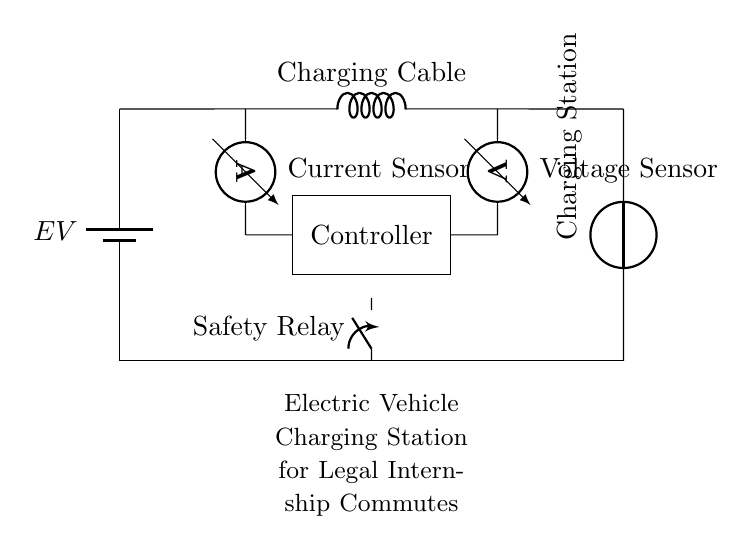What is the primary component generating power in this circuit? The primary component generating power is the charging station, which is depicted as a voltage source in the circuit.
Answer: Charging Station What type of sensor is used to measure current? The current sensor in the circuit is an ammeter, which is specifically designed to measure the flow of electric current.
Answer: Ammeter What does the safety relay do in this circuit? The safety relay functions as a switch that can open or close the circuit, ensuring safety during charging to prevent faults or overloads.
Answer: Closing Switch How many sensors are included in the charging circuit? There are two sensors present in the circuit diagram: an ammeter to measure current and a voltmeter to measure voltage.
Answer: Two What is the purpose of the controller in this circuit? The controller regulates the charging process, managing the flow of electricity from the charging station to the electric vehicle's battery.
Answer: Regulate Charging What connects the electric vehicle to the charging station? The charging cable connects the electric vehicle to the charging station, allowing electrical energy to flow from the station to the vehicle.
Answer: Charging Cable 